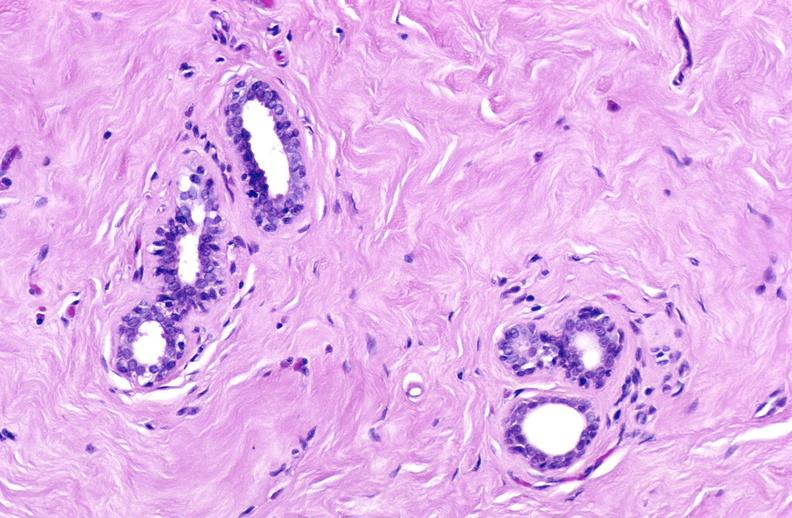where is this area in the body?
Answer the question using a single word or phrase. Breast 